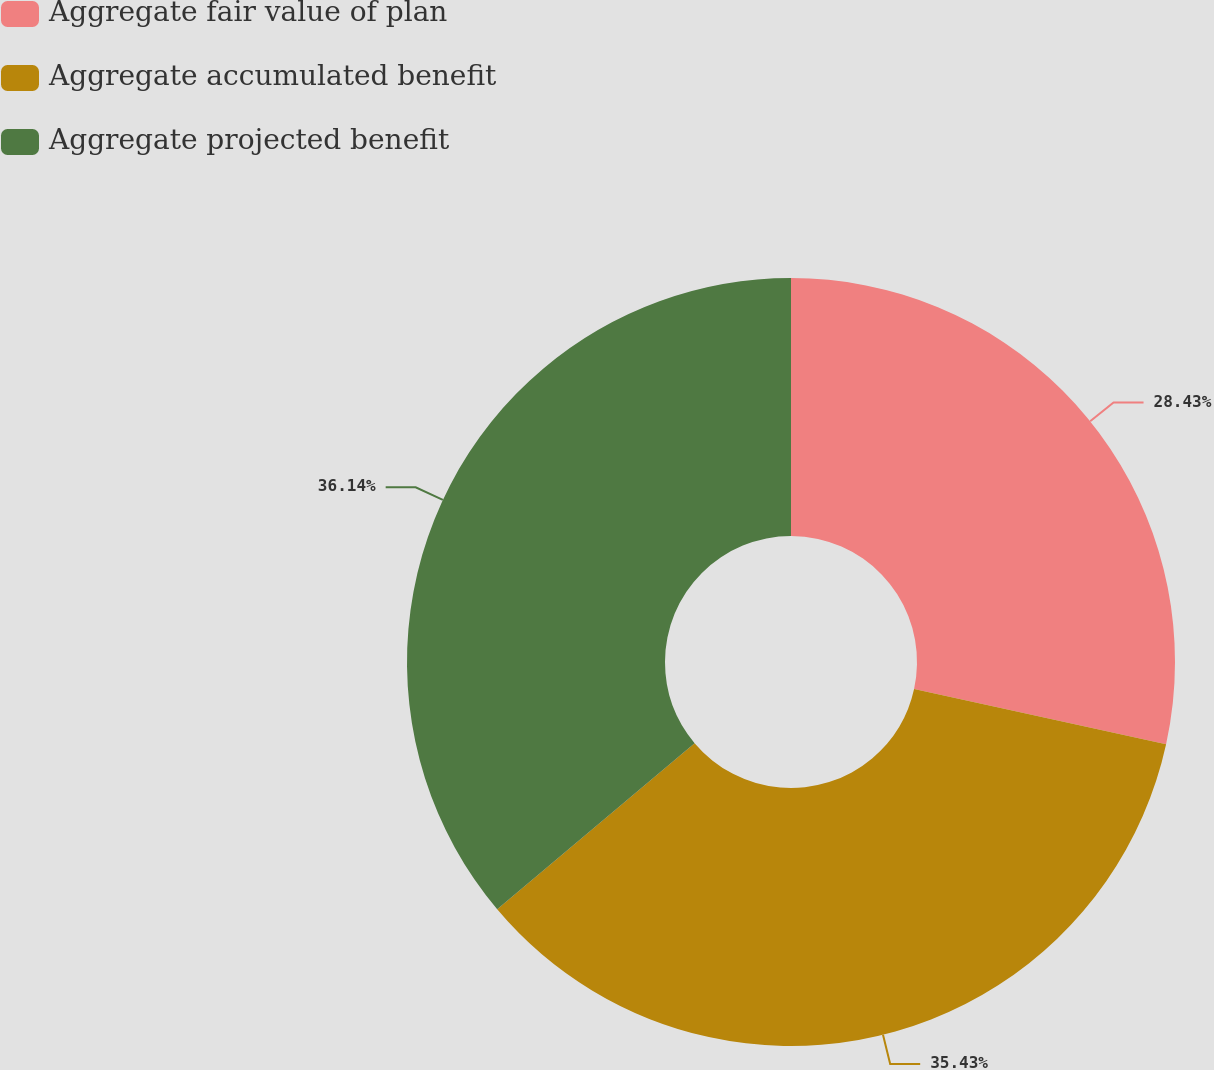Convert chart to OTSL. <chart><loc_0><loc_0><loc_500><loc_500><pie_chart><fcel>Aggregate fair value of plan<fcel>Aggregate accumulated benefit<fcel>Aggregate projected benefit<nl><fcel>28.43%<fcel>35.43%<fcel>36.13%<nl></chart> 